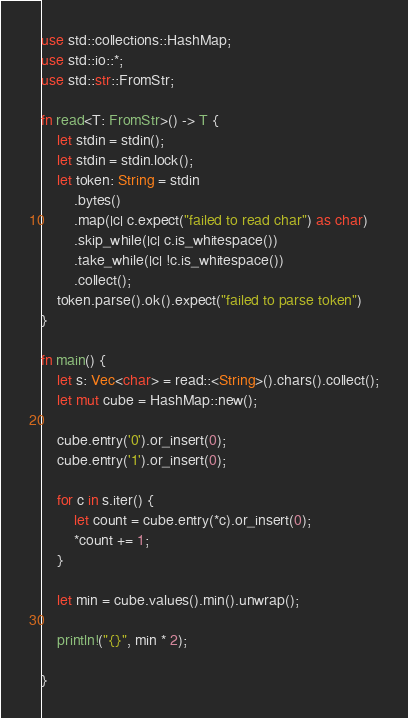<code> <loc_0><loc_0><loc_500><loc_500><_Rust_>use std::collections::HashMap;
use std::io::*;
use std::str::FromStr;

fn read<T: FromStr>() -> T {
    let stdin = stdin();
    let stdin = stdin.lock();
    let token: String = stdin
        .bytes()
        .map(|c| c.expect("failed to read char") as char)
        .skip_while(|c| c.is_whitespace())
        .take_while(|c| !c.is_whitespace())
        .collect();
    token.parse().ok().expect("failed to parse token")
}
 
fn main() {
    let s: Vec<char> = read::<String>().chars().collect();
    let mut cube = HashMap::new();
 
    cube.entry('0').or_insert(0);
    cube.entry('1').or_insert(0);
 
    for c in s.iter() {
        let count = cube.entry(*c).or_insert(0);
        *count += 1;
    }
 
    let min = cube.values().min().unwrap();
 
    println!("{}", min * 2);
    
}
</code> 